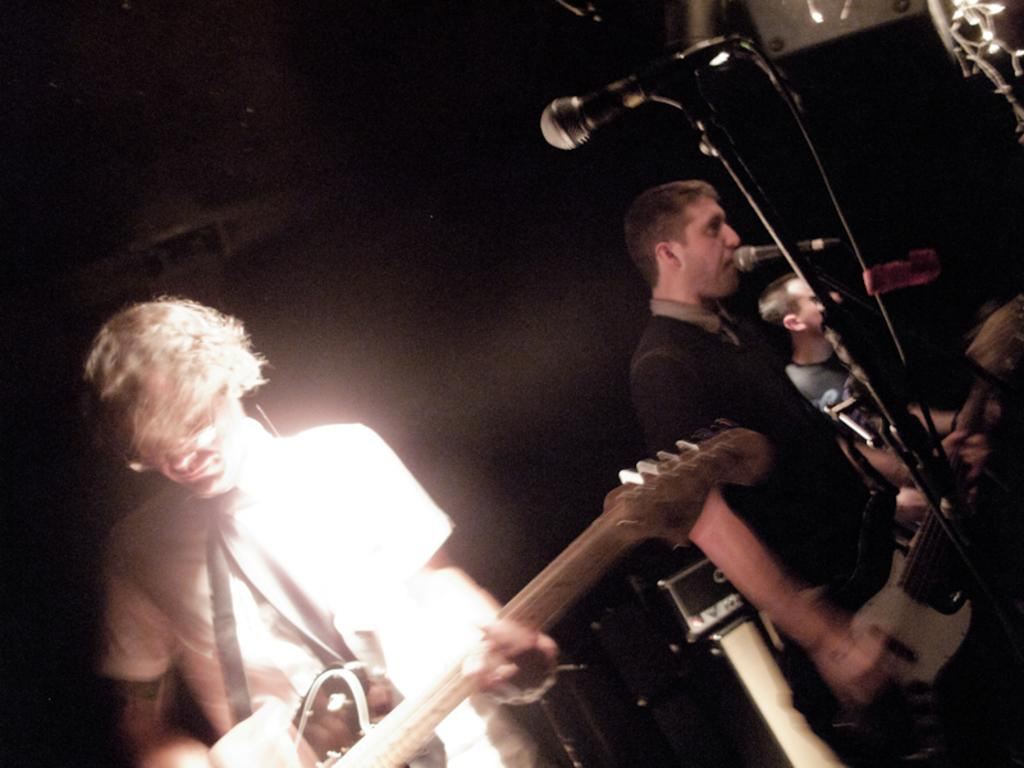What is the man in the image doing? The man is singing into a microphone. Are there any other people involved in the activity in the image? Yes, there is another man playing a musical instrument in the image. Can you describe the background of the image? The background of the image is blurred. What type of tomatoes can be seen in the background of the image? There are no tomatoes present in the image; the background is blurred. 